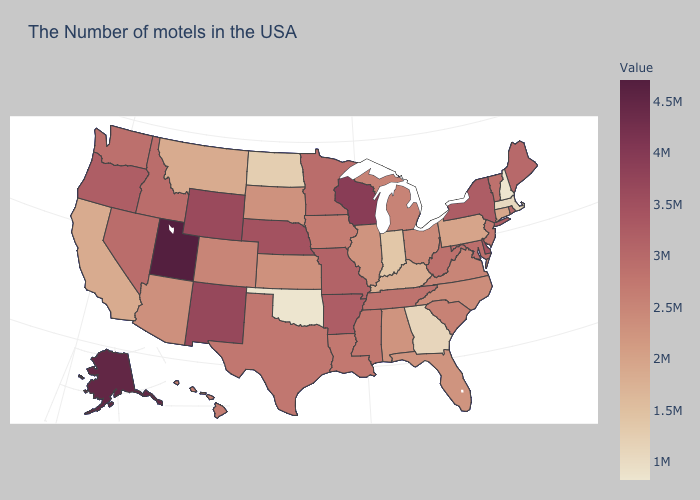Which states have the lowest value in the Northeast?
Short answer required. New Hampshire. Is the legend a continuous bar?
Quick response, please. Yes. Does the map have missing data?
Keep it brief. No. Which states have the highest value in the USA?
Write a very short answer. Utah. Does the map have missing data?
Write a very short answer. No. 